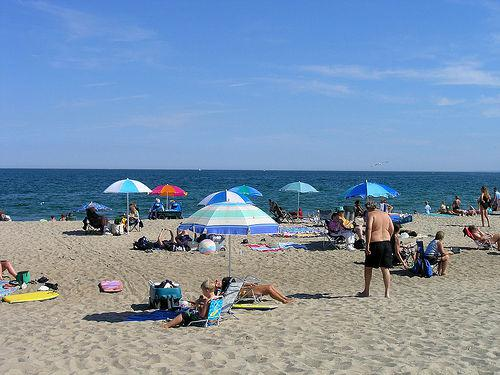Question: what other color is the pink umbrella?
Choices:
A. Orange.
B. Grey.
C. Blue.
D. Black.
Answer with the letter. Answer: A Question: why is it so bright?
Choices:
A. Daylight.
B. Sunny.
C. Clear skies.
D. Early morning.
Answer with the letter. Answer: B Question: where was the photo taken?
Choices:
A. The park.
B. The church.
C. The beach.
D. The restaurant.
Answer with the letter. Answer: C 